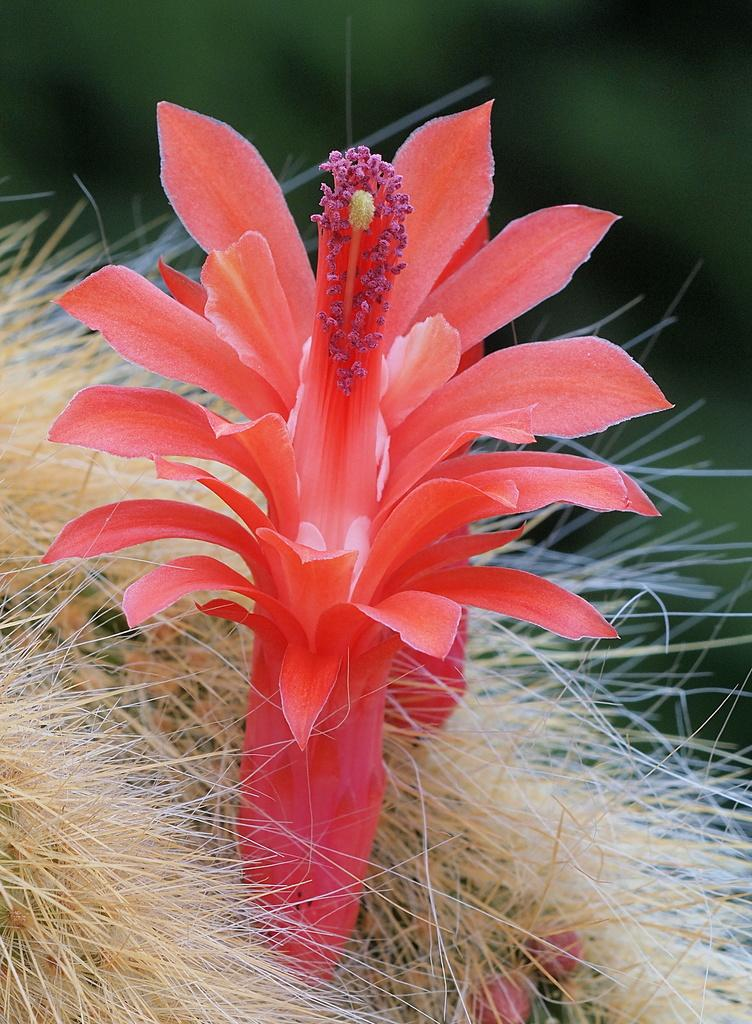What is the main subject of the image? There is a flower in the image. Can you describe the background of the image? The background of the image is blurred. Is the flower poisonous in the image? There is no information provided about the flower being poisonous, so we cannot determine that from the image. Who is the owner of the flower in the image? There is no indication of an owner in the image, as it only features a flower and a blurred background. 